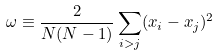Convert formula to latex. <formula><loc_0><loc_0><loc_500><loc_500>\omega \equiv \frac { 2 } { N ( N - 1 ) } \sum _ { i > j } ( x _ { i } - x _ { j } ) ^ { 2 }</formula> 